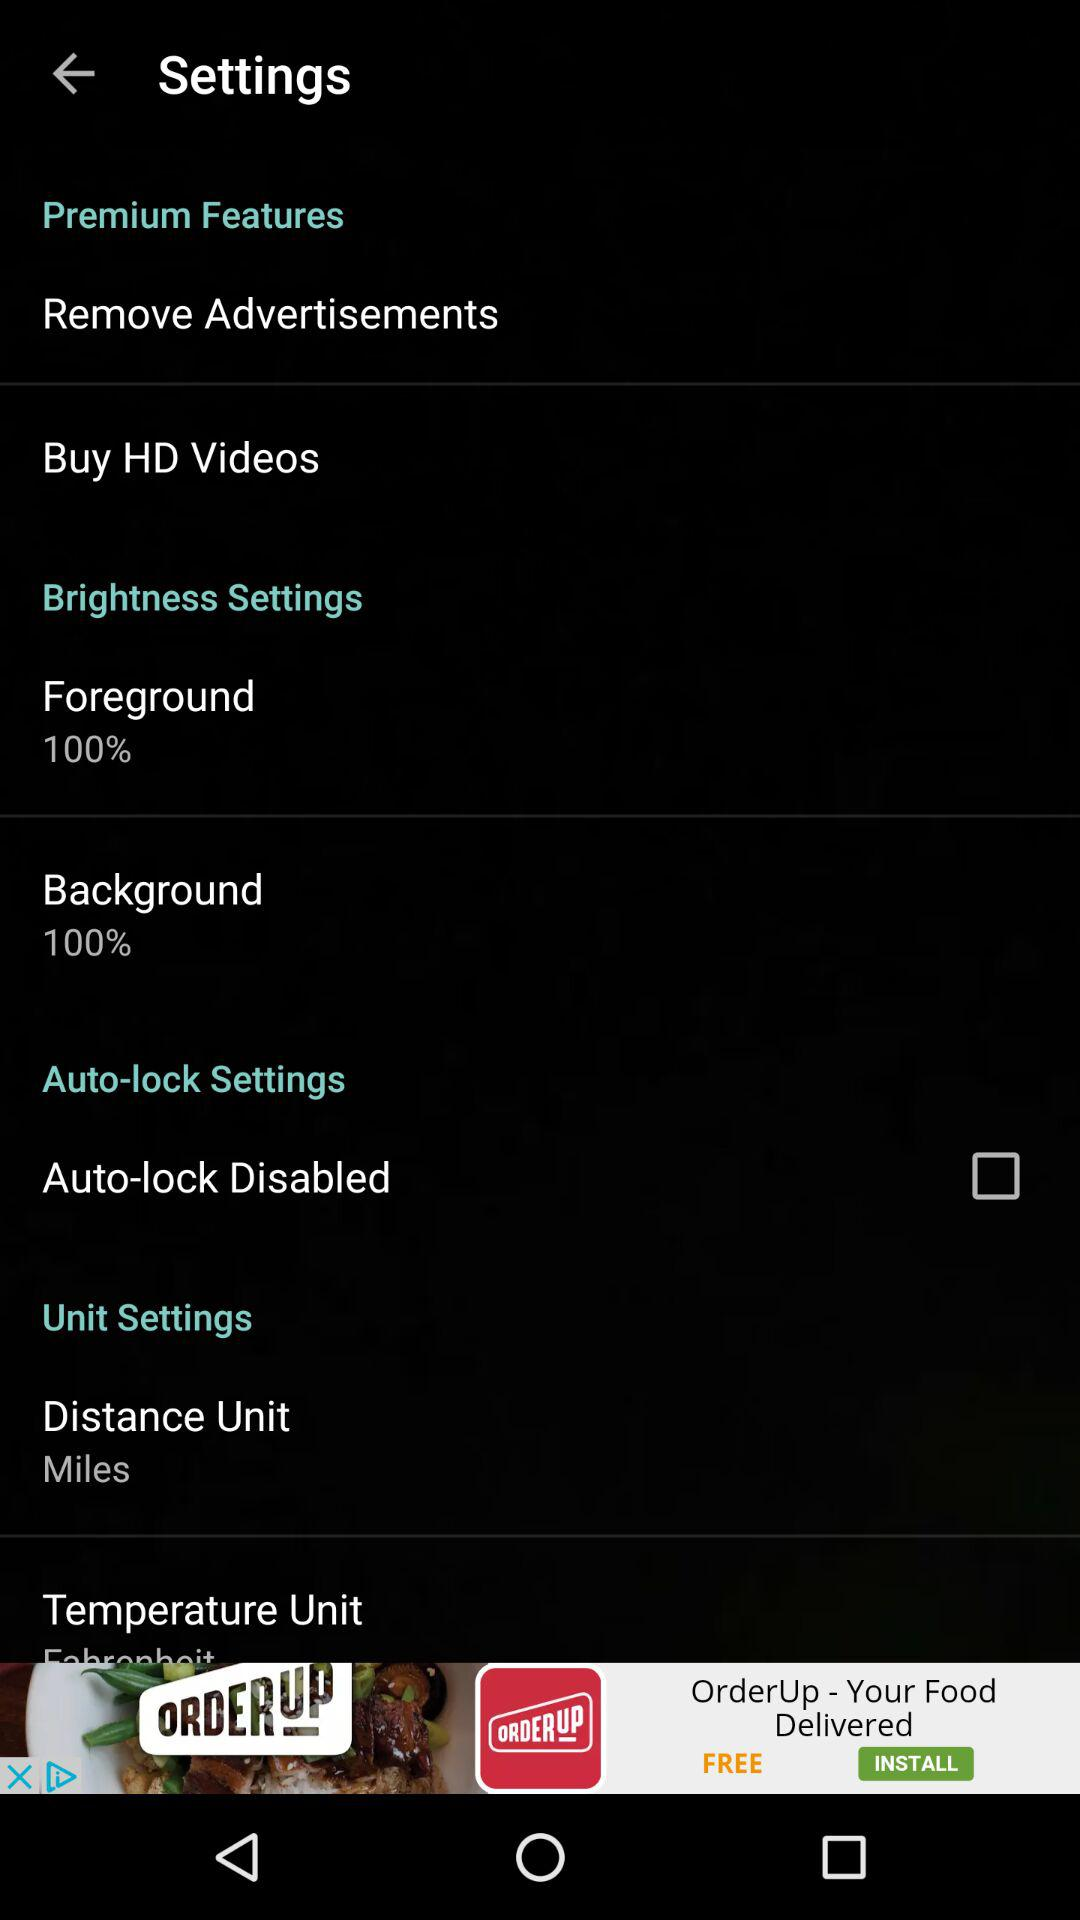How many premium features are available?
Answer the question using a single word or phrase. 2 